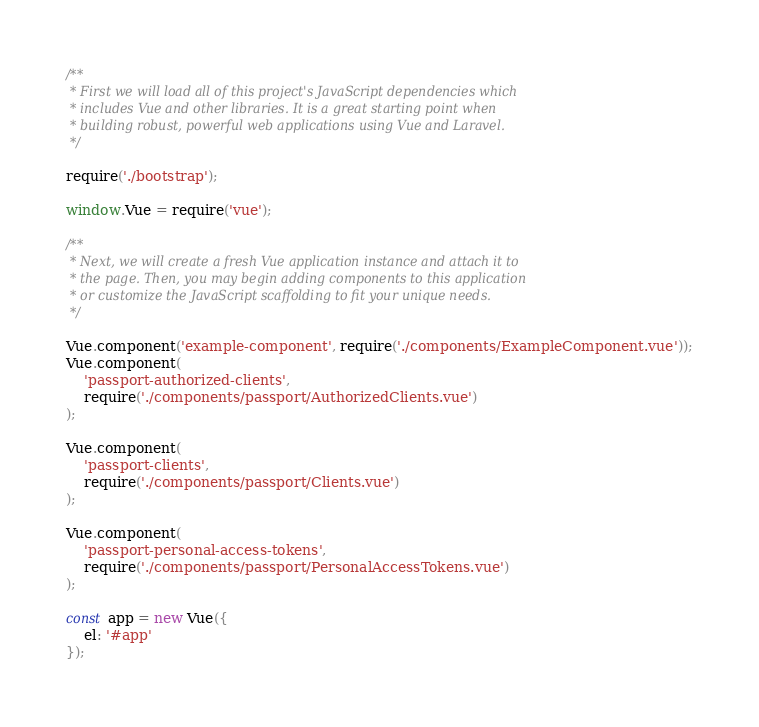<code> <loc_0><loc_0><loc_500><loc_500><_JavaScript_>
/**
 * First we will load all of this project's JavaScript dependencies which
 * includes Vue and other libraries. It is a great starting point when
 * building robust, powerful web applications using Vue and Laravel.
 */

require('./bootstrap');

window.Vue = require('vue');

/**
 * Next, we will create a fresh Vue application instance and attach it to
 * the page. Then, you may begin adding components to this application
 * or customize the JavaScript scaffolding to fit your unique needs.
 */

Vue.component('example-component', require('./components/ExampleComponent.vue'));
Vue.component(
    'passport-authorized-clients',
    require('./components/passport/AuthorizedClients.vue')
);

Vue.component(
    'passport-clients',
    require('./components/passport/Clients.vue')
);

Vue.component(
    'passport-personal-access-tokens',
    require('./components/passport/PersonalAccessTokens.vue')
);

const app = new Vue({
    el: '#app'
});


</code> 